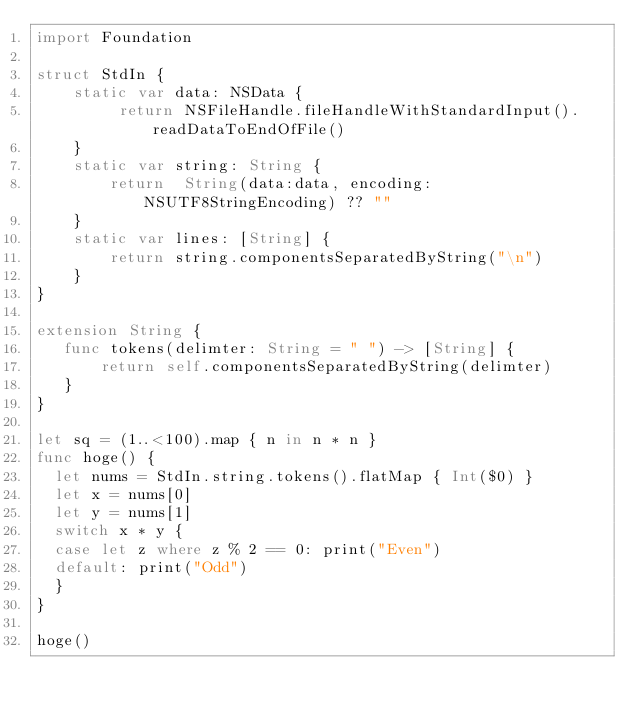Convert code to text. <code><loc_0><loc_0><loc_500><loc_500><_Swift_>import Foundation
 
struct StdIn {
    static var data: NSData {
         return NSFileHandle.fileHandleWithStandardInput().readDataToEndOfFile()
    }
    static var string: String {
        return  String(data:data, encoding:NSUTF8StringEncoding) ?? ""
    }
    static var lines: [String] {
        return string.componentsSeparatedByString("\n")
    }
}
 
extension String {
   func tokens(delimter: String = " ") -> [String] {
       return self.componentsSeparatedByString(delimter)
   }
}

let sq = (1..<100).map { n in n * n }
func hoge() {
  let nums = StdIn.string.tokens().flatMap { Int($0) }
  let x = nums[0]
  let y = nums[1]
  switch x * y {
  case let z where z % 2 == 0: print("Even")
  default: print("Odd")
  }  
}

hoge()</code> 